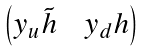Convert formula to latex. <formula><loc_0><loc_0><loc_500><loc_500>\begin{pmatrix} y _ { u } \tilde { h } \, & \, y _ { d } h \\ \end{pmatrix}</formula> 